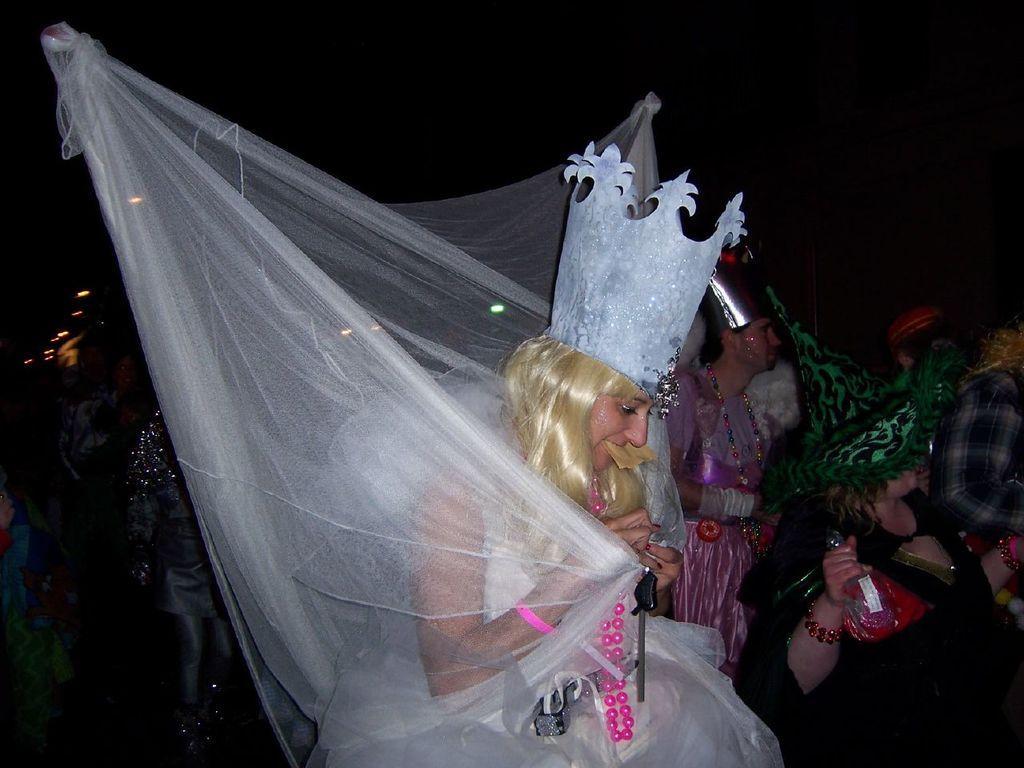Describe this image in one or two sentences. In this image we can see group of persons. There are few persons holding objects. On the left side, we can see the lights. The background of the image is dark. 